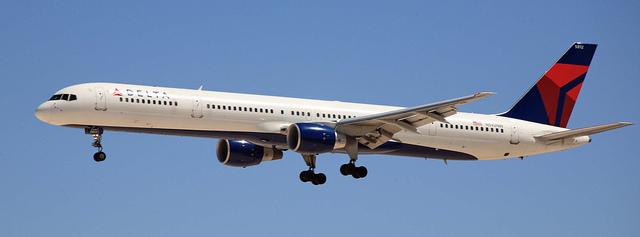What size is the airplane?
Give a very brief answer. 747. What color are the engines?
Quick response, please. Blue. Does this plane have its landing gear down?
Short answer required. Yes. 